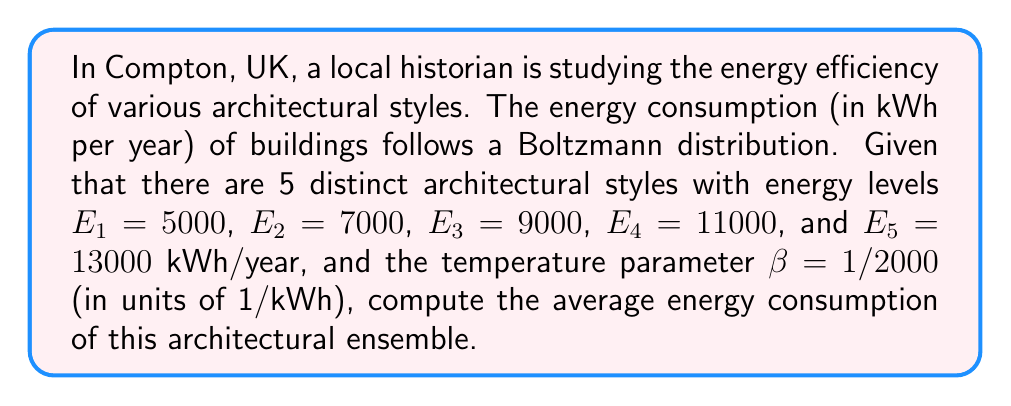Provide a solution to this math problem. To solve this problem, we'll use the principles of statistical mechanics:

1) The average energy of a system in thermal equilibrium is given by:

   $$\langle E \rangle = \frac{\sum_{i} E_i e^{-\beta E_i}}{\sum_{i} e^{-\beta E_i}}$$

2) Let's calculate the denominator first (partition function Z):

   $$Z = \sum_{i} e^{-\beta E_i} = e^{-5000/2000} + e^{-7000/2000} + e^{-9000/2000} + e^{-11000/2000} + e^{-13000/2000}$$
   
   $$Z = e^{-2.5} + e^{-3.5} + e^{-4.5} + e^{-5.5} + e^{-6.5} \approx 0.0821 + 0.0302 + 0.0111 + 0.0041 + 0.0015 \approx 0.1290$$

3) Now, let's calculate the numerator:

   $$\sum_{i} E_i e^{-\beta E_i} = 5000e^{-2.5} + 7000e^{-3.5} + 9000e^{-4.5} + 11000e^{-5.5} + 13000e^{-6.5}$$
   
   $$\approx 410.5 + 211.4 + 99.9 + 45.1 + 19.5 \approx 786.4$$

4) Finally, we can calculate the average energy:

   $$\langle E \rangle = \frac{786.4}{0.1290} \approx 6096.9 \text{ kWh/year}$$
Answer: 6096.9 kWh/year 